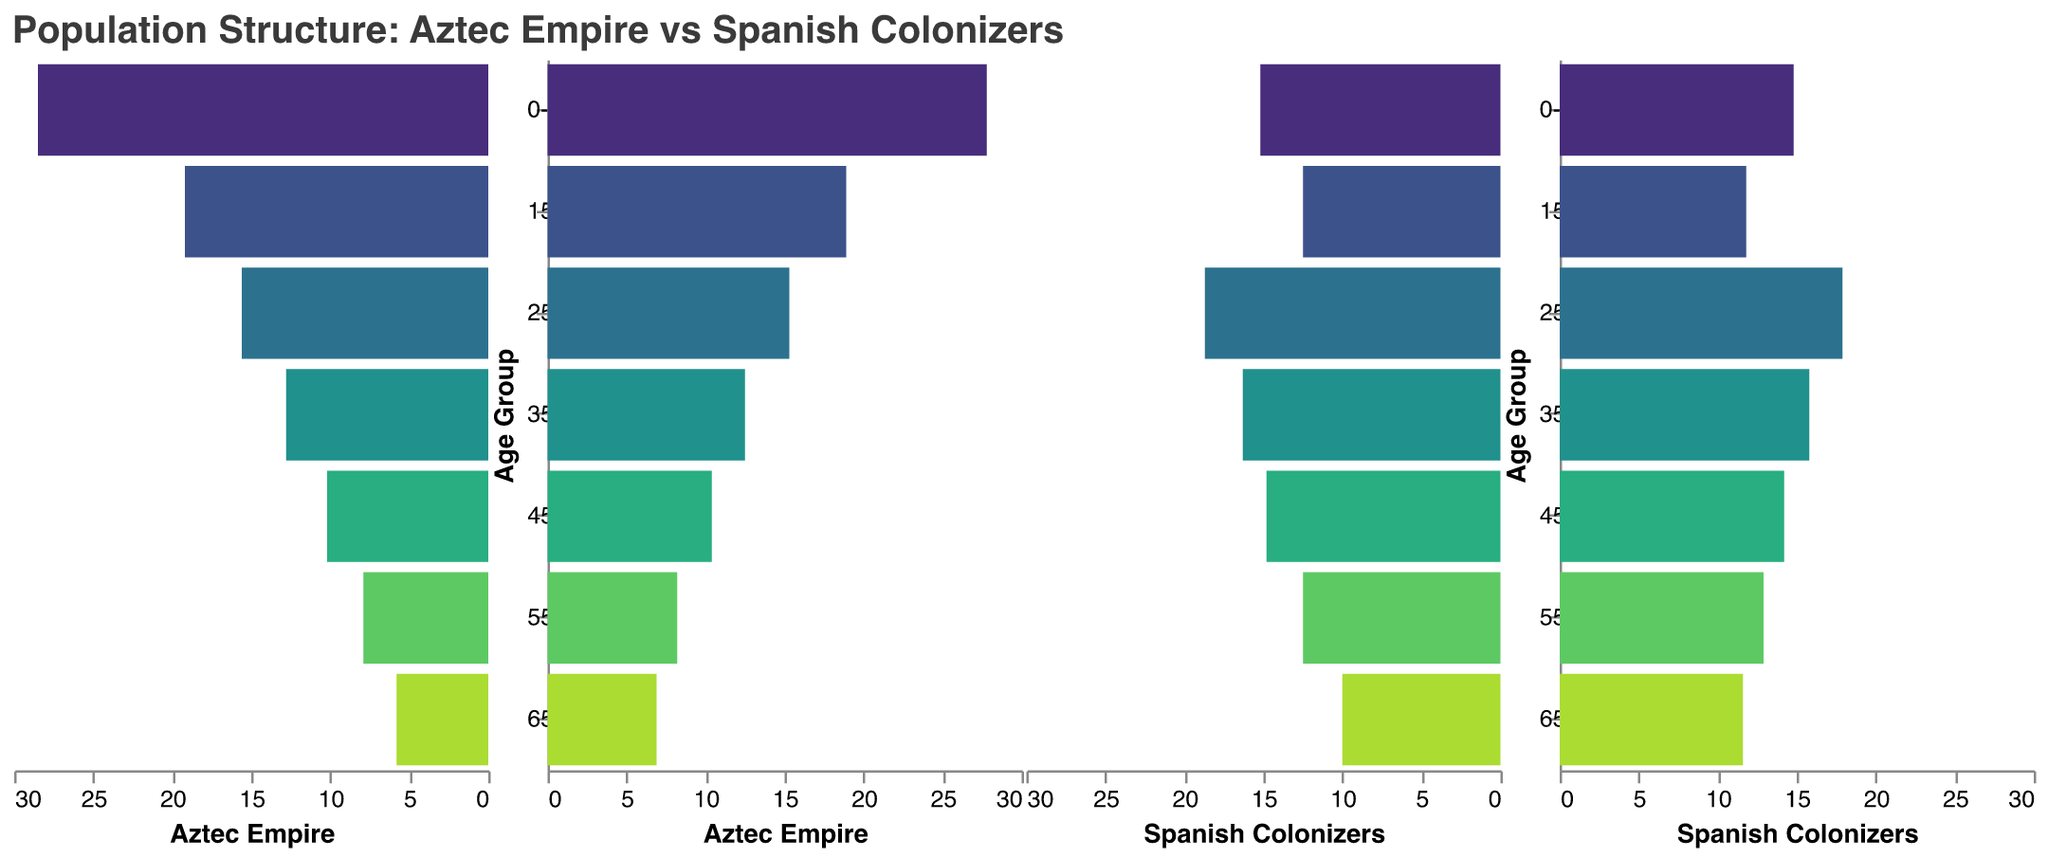What is the title of the figure? The figure's title is usually located at the top and provides a concise summary of the visual data represented below it. Looking at the figure, the title mentioned is "Population Structure: Aztec Empire vs Spanish Colonizers".
Answer: Population Structure: Aztec Empire vs Spanish Colonizers Which age group has the largest percentage of Aztec Empire females? To find this, look at the bars on the right side of the segment labeled "Aztec Empire" for females. The age group "0-14" has the longest bar, indicating it has the highest percentage.
Answer: 0-14 In which age group do the Spanish Colonizers have the highest percentage of males? To determine this, examine the negative x-axis bars on the section for Spanish Colonizers males. The "25-34" age group has the longest bar, indicating the highest percentage.
Answer: 25-34 Compare the 65+ age group between Aztec Empire females and Spanish Colonizer females. Which group has a higher percentage? Look at the bars for the age group labeled "65+" for both Aztec Empire females (6.9%) and Spanish Colonizers females (11.6%). The Spanish colonizer females have a higher percentage.
Answer: Spanish Colonizers How much higher is the percentage of 0-14 age group in the Aztec Empire compared to the Spanish Colonizers? Find the difference between the percentages of the "0-14" age group: Aztec Empire (28.5+27.8=56.3%) and Spanish Colonizers (15.2+14.8=30%). Subtract the two sums 56.3% - 30% = 26.3%.
Answer: 26.3% Which age group has the smallest percentage difference between Aztec Empire males and females? To find this, look for the smallest difference between percentages of males and females within each age group for the Aztec Empire. The "45-54" age group has the smallest difference:
Answer: 45-54 Which age group shows a higher percentage of males for Spanish Colonizers compared to Aztec Empire? Examine each age group and compare the male percentages of Spanish Colonizers and Aztec Empire. The age groups "25-34", "35-44", "45-54", and "55-64" all show higher percentages of males for the Spanish Colonizers compared to the Aztec Empire.
Answer: 25-34, 35-44, 45-54, 55-64 What is the total percentage of Aztec Empire (male and female) in the 15-24 age group? Add the male percentage (19.2) and the female percentage (18.9) for the Aztec Empire's 15-24 age group: 19.2 + 18.9 = 38.1%.
Answer: 38.1% Which age group has a higher ratio of females to males in the Aztec Empire? Determine the ratio of females to males by dividing the female percentage by the male percentage for each age group. The ratios are: 0-14: 27.8/28.5, 15-24: 18.9/19.2, 25-34: 15.3/15.6, etc. The 45-54 age group has the highest ratio (10.4/10.2 > 1).
Answer: 45-54 